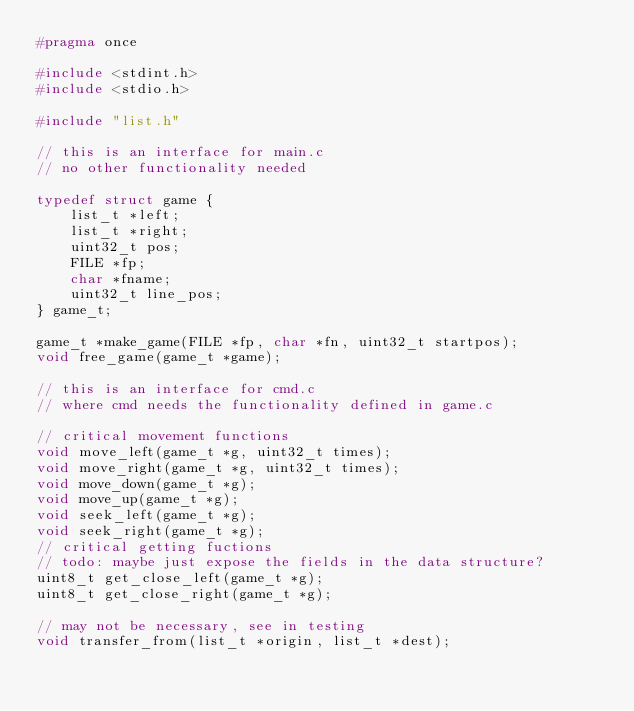Convert code to text. <code><loc_0><loc_0><loc_500><loc_500><_C_>#pragma once

#include <stdint.h>
#include <stdio.h>

#include "list.h"

// this is an interface for main.c
// no other functionality needed

typedef struct game {
    list_t *left;
    list_t *right;
    uint32_t pos; 
    FILE *fp;
    char *fname;
    uint32_t line_pos;
} game_t;

game_t *make_game(FILE *fp, char *fn, uint32_t startpos);
void free_game(game_t *game);

// this is an interface for cmd.c
// where cmd needs the functionality defined in game.c

// critical movement functions
void move_left(game_t *g, uint32_t times);
void move_right(game_t *g, uint32_t times);
void move_down(game_t *g);
void move_up(game_t *g);
void seek_left(game_t *g);
void seek_right(game_t *g);
// critical getting fuctions
// todo: maybe just expose the fields in the data structure?
uint8_t get_close_left(game_t *g);
uint8_t get_close_right(game_t *g);

// may not be necessary, see in testing
void transfer_from(list_t *origin, list_t *dest);
</code> 